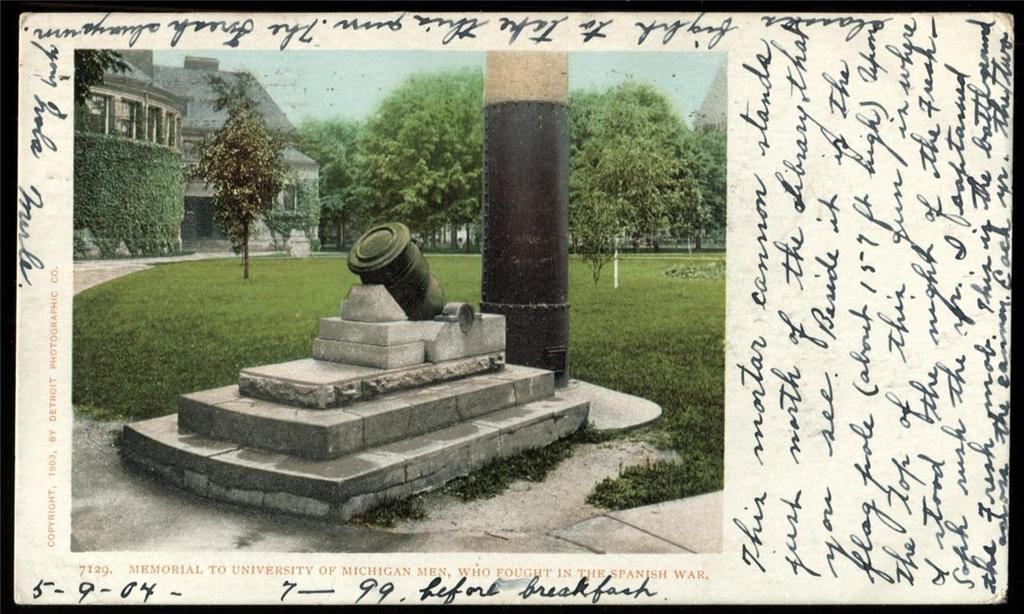What is on the paper that is visible in the image? The paper contains words, numbers, and a photo of a house. What type of landscape elements are depicted on the paper? Grass, trees, and the sky are depicted on the paper. Is there a volcano erupting in the image? No, there is no volcano present in the image. How can we help the trees depicted on the paper? The trees depicted on the paper are not real, so there is no way to help them. 